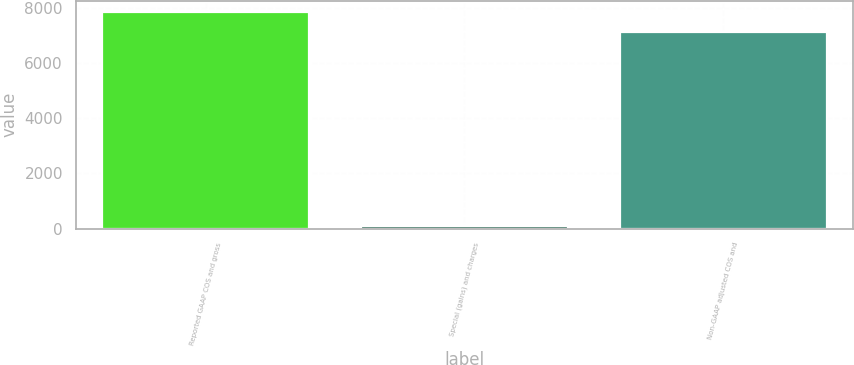Convert chart to OTSL. <chart><loc_0><loc_0><loc_500><loc_500><bar_chart><fcel>Reported GAAP COS and gross<fcel>Special (gains) and charges<fcel>Non-GAAP adjusted COS and<nl><fcel>7857.19<fcel>80.6<fcel>7142.9<nl></chart> 